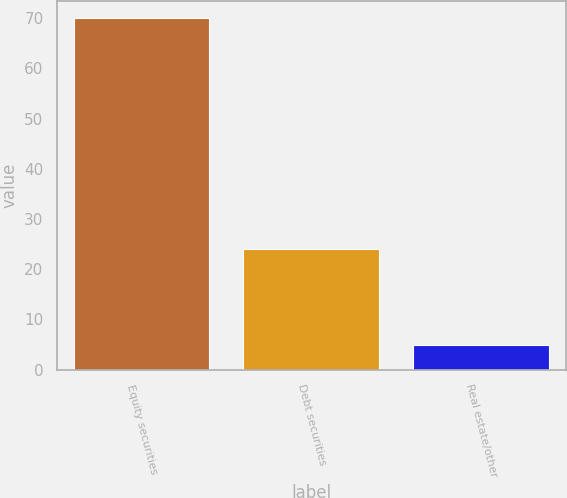Convert chart. <chart><loc_0><loc_0><loc_500><loc_500><bar_chart><fcel>Equity securities<fcel>Debt securities<fcel>Real estate/other<nl><fcel>70<fcel>24<fcel>5<nl></chart> 